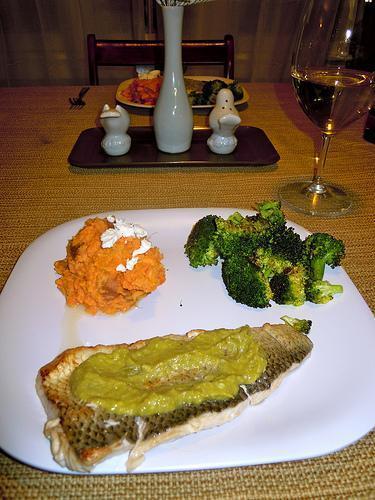How many vegetables are on the plate?
Give a very brief answer. 2. 